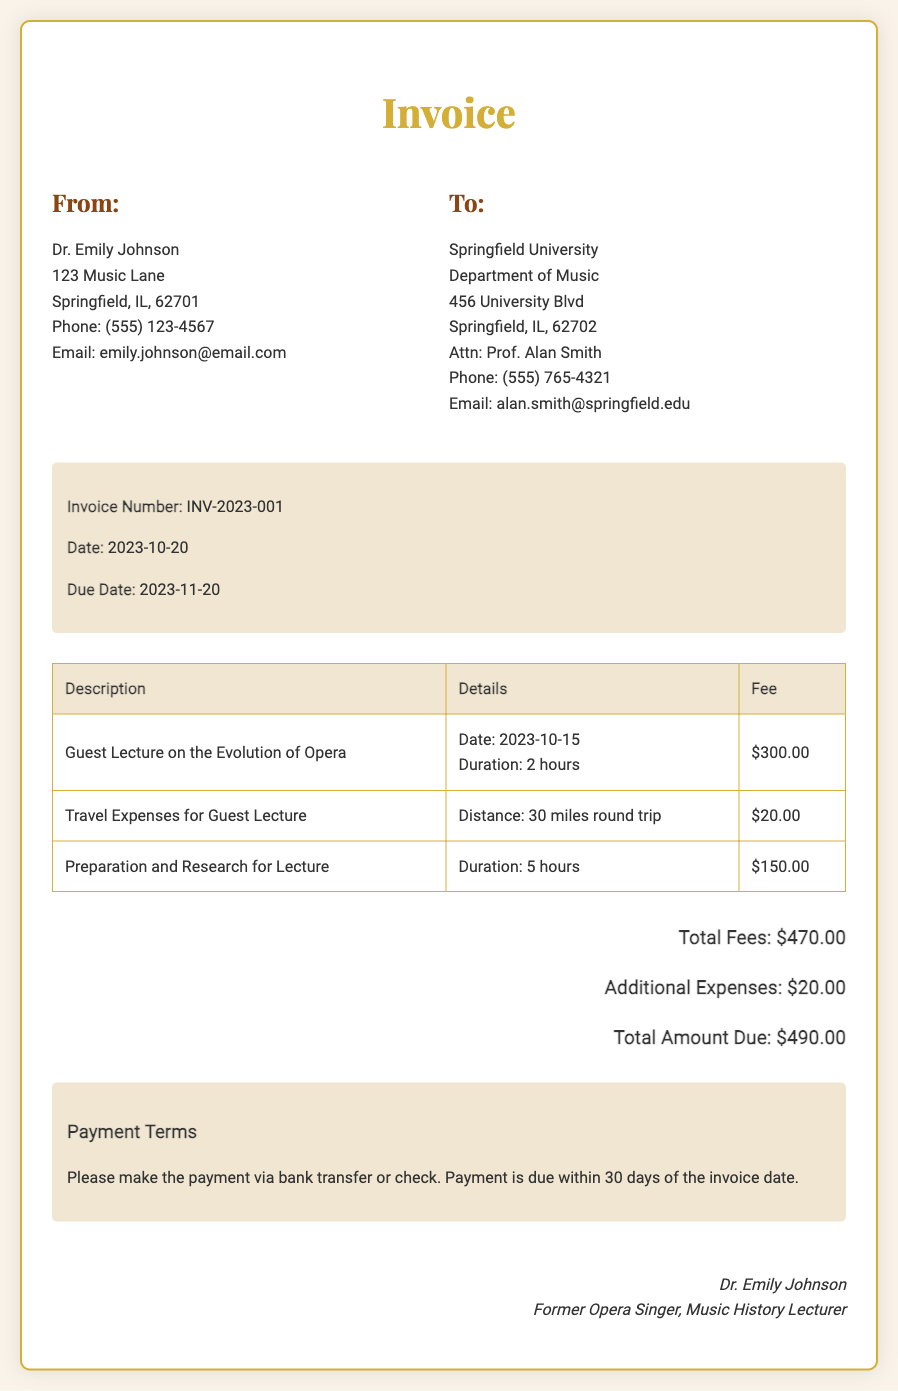What is the invoice number? The invoice number is clearly stated in the invoice details section of the document.
Answer: INV-2023-001 Who is the recipient of the invoice? The recipient's information is provided under the "To:" section of the document.
Answer: Springfield University What is the total amount due? The total amount due is summarized at the bottom of the invoice, including all fees and expenses.
Answer: $490.00 What date was the guest lecture delivered? The date of the guest lecture is mentioned in the itemized list of services rendered.
Answer: 2023-10-15 How much was charged for preparation and research? The fee for preparation and research is listed in the table with corresponding fees.
Answer: $150.00 What is the payment term duration? The payment terms state the duration for which the payment is due, reflecting standard practice for invoices.
Answer: 30 days What was the travel distance incurred? The travel distance is mentioned in the detail of the travel expenses row in the table.
Answer: 30 miles round trip In what capacity does Dr. Emily Johnson sign the invoice? The signature section of the invoice states Dr. Johnson's role.
Answer: Music History Lecturer 